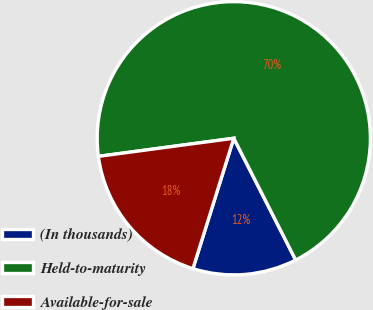<chart> <loc_0><loc_0><loc_500><loc_500><pie_chart><fcel>(In thousands)<fcel>Held-to-maturity<fcel>Available-for-sale<nl><fcel>12.32%<fcel>69.63%<fcel>18.05%<nl></chart> 